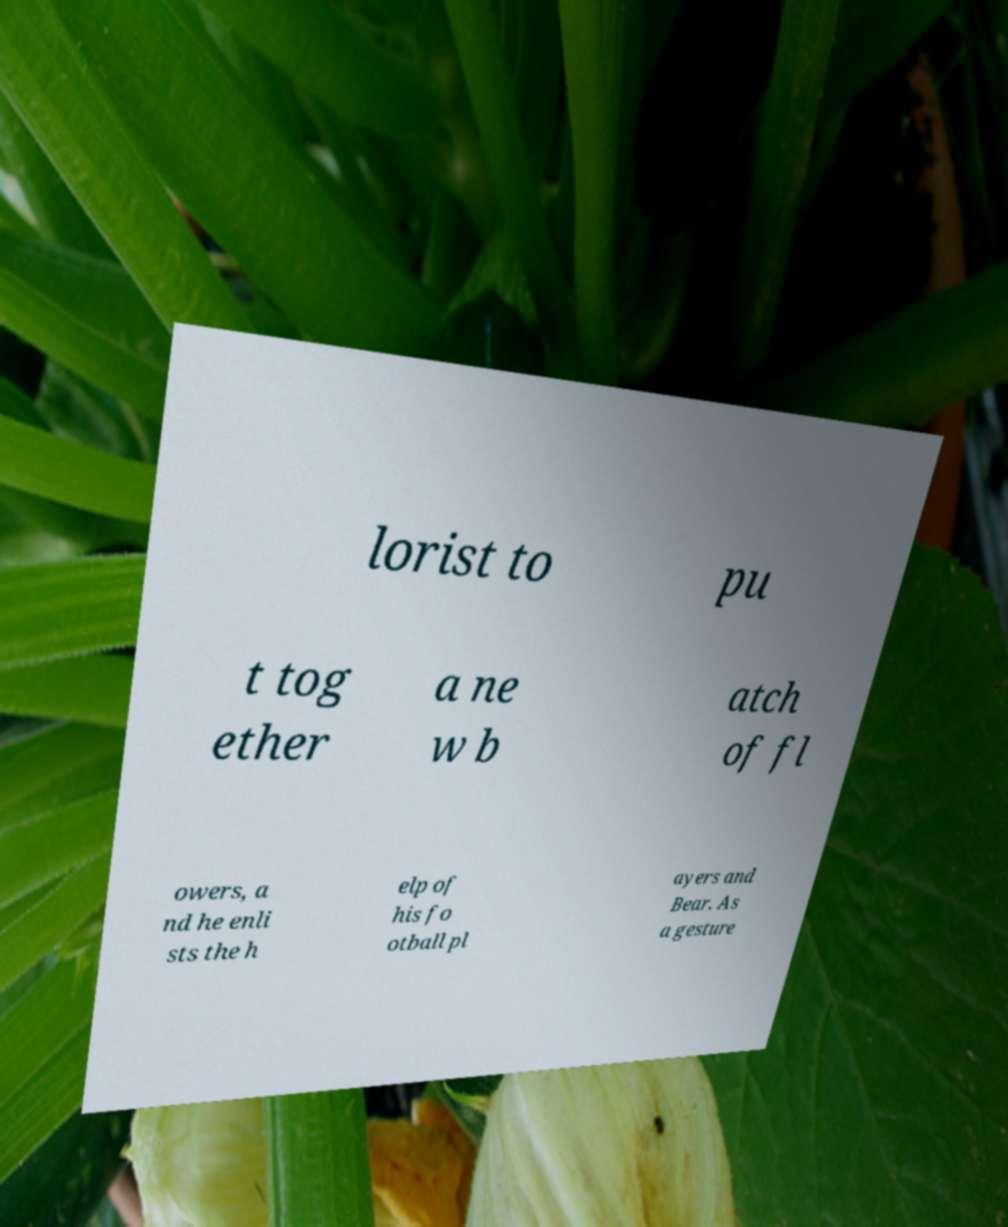For documentation purposes, I need the text within this image transcribed. Could you provide that? lorist to pu t tog ether a ne w b atch of fl owers, a nd he enli sts the h elp of his fo otball pl ayers and Bear. As a gesture 